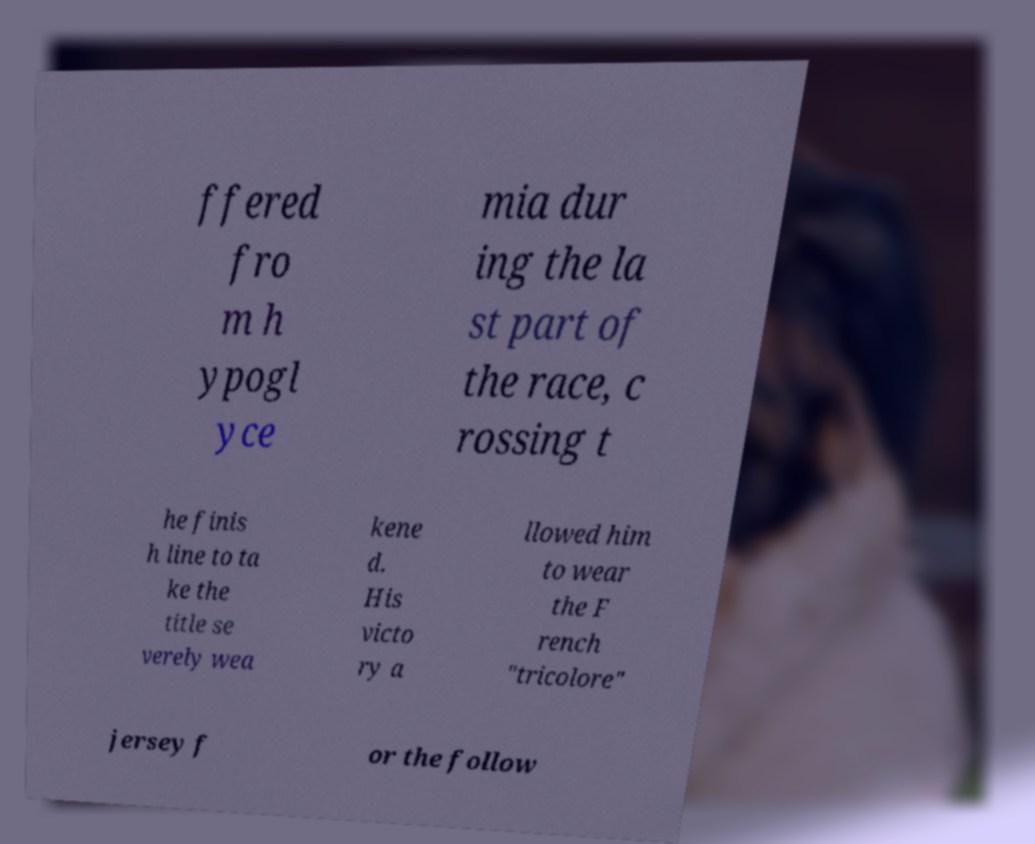I need the written content from this picture converted into text. Can you do that? ffered fro m h ypogl yce mia dur ing the la st part of the race, c rossing t he finis h line to ta ke the title se verely wea kene d. His victo ry a llowed him to wear the F rench "tricolore" jersey f or the follow 